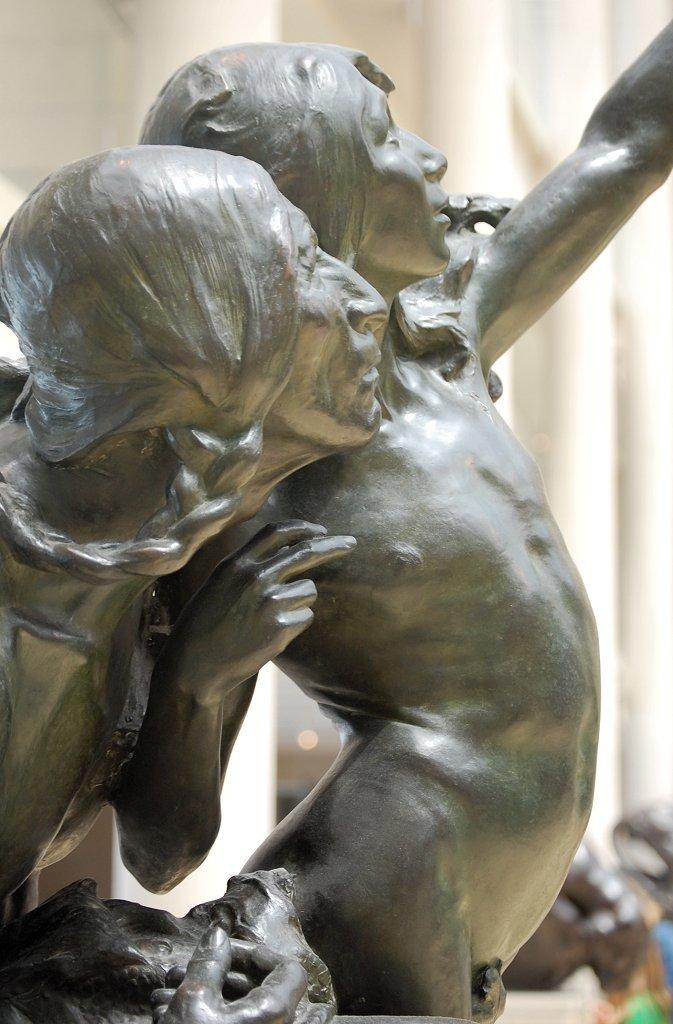What can be seen in the image? There are statues in the image. What is visible in the background of the image? There is a wall in the background of the image. What type of lock is used to secure the goat in the image? There is no goat present in the image, and therefore no lock is needed to secure it. 